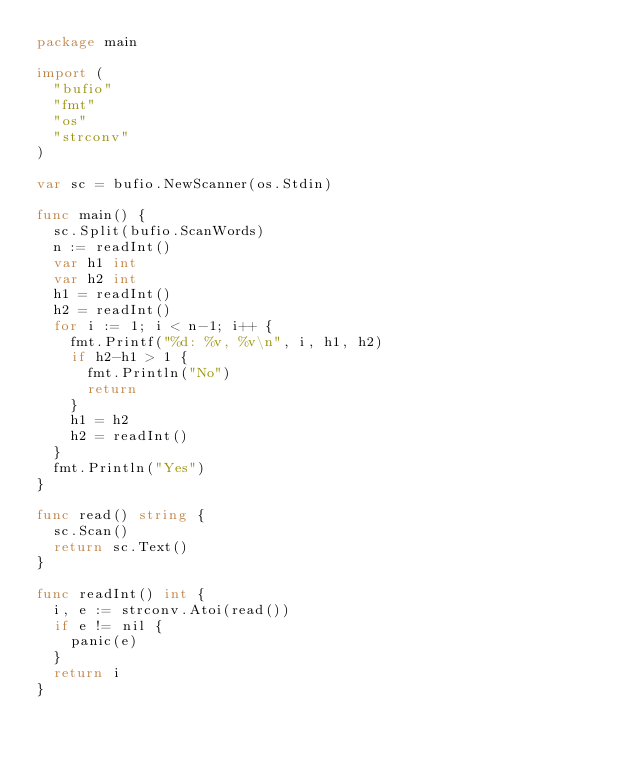<code> <loc_0><loc_0><loc_500><loc_500><_Go_>package main

import (
	"bufio"
	"fmt"
	"os"
	"strconv"
)

var sc = bufio.NewScanner(os.Stdin)

func main() {
	sc.Split(bufio.ScanWords)
	n := readInt()
	var h1 int
	var h2 int
	h1 = readInt()
	h2 = readInt()
	for i := 1; i < n-1; i++ {
		fmt.Printf("%d: %v, %v\n", i, h1, h2)
		if h2-h1 > 1 {
			fmt.Println("No")
			return
		}
		h1 = h2
		h2 = readInt()
	}
	fmt.Println("Yes")
}

func read() string {
	sc.Scan()
	return sc.Text()
}

func readInt() int {
	i, e := strconv.Atoi(read())
	if e != nil {
		panic(e)
	}
	return i
}
</code> 